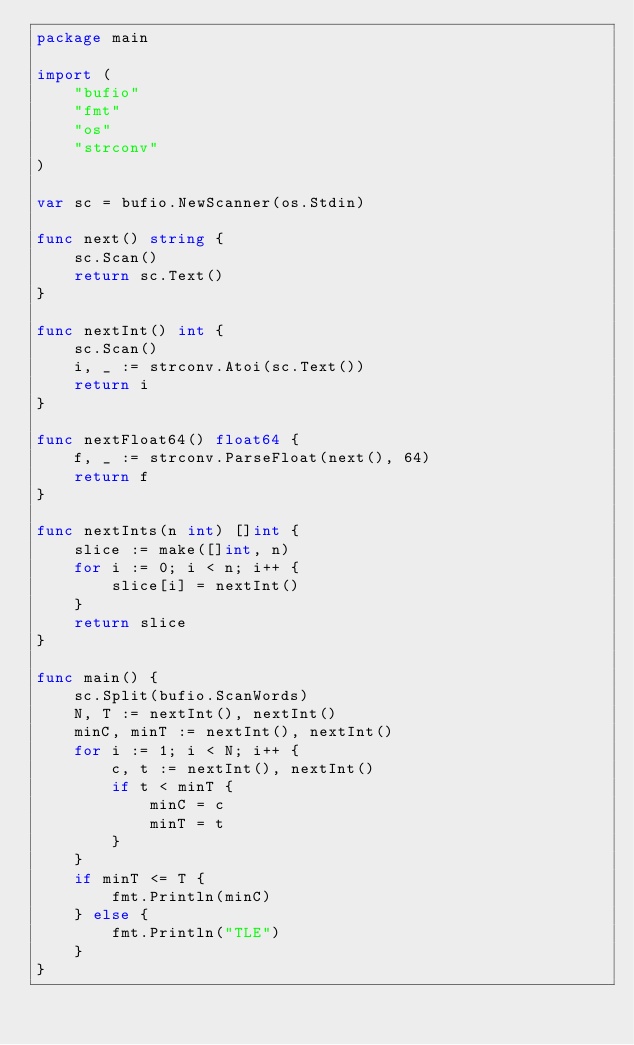<code> <loc_0><loc_0><loc_500><loc_500><_Go_>package main

import (
	"bufio"
	"fmt"
	"os"
	"strconv"
)

var sc = bufio.NewScanner(os.Stdin)

func next() string {
	sc.Scan()
	return sc.Text()
}

func nextInt() int {
	sc.Scan()
	i, _ := strconv.Atoi(sc.Text())
	return i
}

func nextFloat64() float64 {
	f, _ := strconv.ParseFloat(next(), 64)
	return f
}

func nextInts(n int) []int {
	slice := make([]int, n)
	for i := 0; i < n; i++ {
		slice[i] = nextInt()
	}
	return slice
}

func main() {
	sc.Split(bufio.ScanWords)
	N, T := nextInt(), nextInt()
	minC, minT := nextInt(), nextInt()
	for i := 1; i < N; i++ {
		c, t := nextInt(), nextInt()
		if t < minT {
			minC = c
			minT = t
		}
	}
	if minT <= T {
		fmt.Println(minC)
	} else {
		fmt.Println("TLE")
	}
}
</code> 